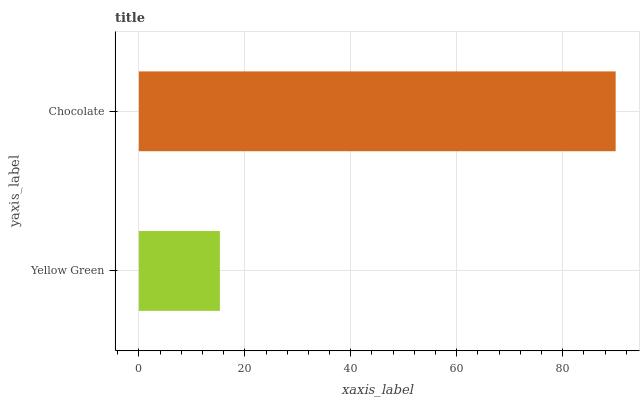Is Yellow Green the minimum?
Answer yes or no. Yes. Is Chocolate the maximum?
Answer yes or no. Yes. Is Chocolate the minimum?
Answer yes or no. No. Is Chocolate greater than Yellow Green?
Answer yes or no. Yes. Is Yellow Green less than Chocolate?
Answer yes or no. Yes. Is Yellow Green greater than Chocolate?
Answer yes or no. No. Is Chocolate less than Yellow Green?
Answer yes or no. No. Is Chocolate the high median?
Answer yes or no. Yes. Is Yellow Green the low median?
Answer yes or no. Yes. Is Yellow Green the high median?
Answer yes or no. No. Is Chocolate the low median?
Answer yes or no. No. 